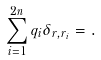Convert formula to latex. <formula><loc_0><loc_0><loc_500><loc_500>\sum _ { i = 1 } ^ { 2 n } q _ { i } \delta _ { r , r _ { i } } = .</formula> 